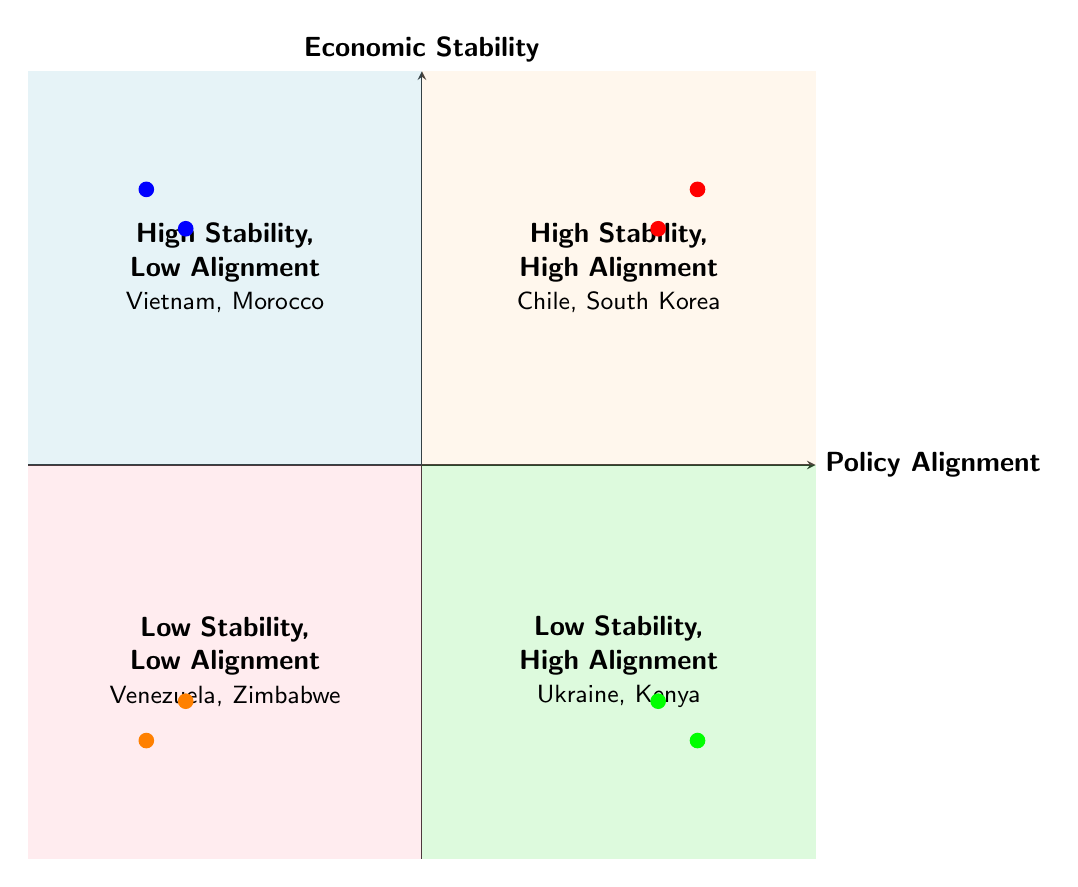What examples are in the "High Stability, Low Alignment" quadrant? The "High Stability, Low Alignment" quadrant is located in the top left section of the diagram. It specifically lists Vietnam and Morocco as examples of countries that fit this category.
Answer: Vietnam, Morocco Which quadrant contains Ukraine? Ukraine is located in the bottom right quadrant of the diagram, which is designated as "Low Stability, High Alignment."
Answer: Low Stability, High Alignment How many countries are listed in the "Low Stability, Low Alignment" quadrant? The "Low Stability, Low Alignment" quadrant is located in the bottom left section of the diagram. It lists two countries: Venezuela and Zimbabwe.
Answer: 2 What is the description of the "High Stability, High Alignment" quadrant? The top right quadrant is labeled "High Stability, High Alignment." The description for this quadrant notes that it includes countries with strong economic stability and high alignment with global policies.
Answer: Countries with strong economic stability coinciding with high alignment to global policies Which quadrant has countries that are aligned with global policies but unstable economically? The quadrant that includes countries aligned with global policies but facing economic instability is the bottom right quadrant, which is labeled as "Low Stability, High Alignment."
Answer: Low Stability, High Alignment 